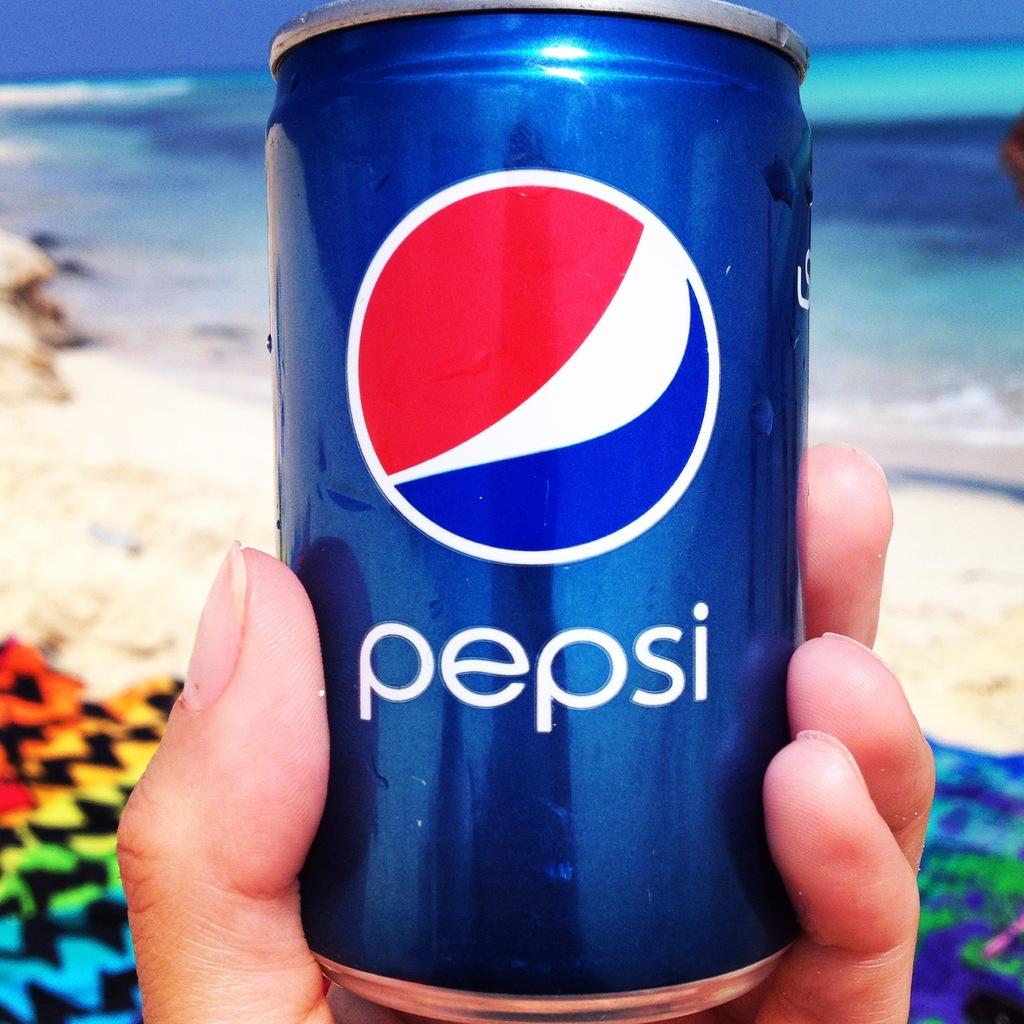What brand of soda is in the can?
Your response must be concise. Pepsi. What is the first letter of the name?
Ensure brevity in your answer.  P. 